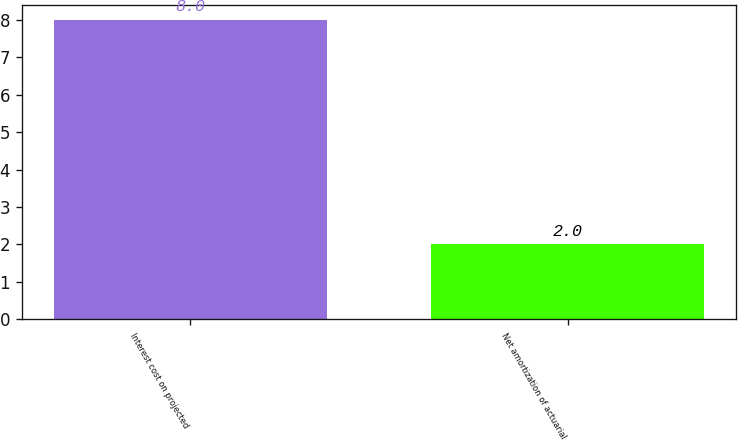<chart> <loc_0><loc_0><loc_500><loc_500><bar_chart><fcel>Interest cost on projected<fcel>Net amortization of actuarial<nl><fcel>8<fcel>2<nl></chart> 